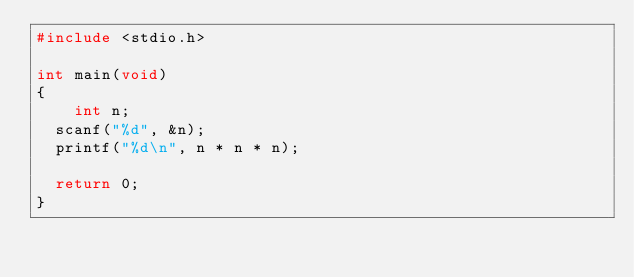<code> <loc_0><loc_0><loc_500><loc_500><_C_>#include <stdio.h>

int main(void)
{
    int n;
	scanf("%d", &n);
	printf("%d\n", n * n * n);

	return 0;
}</code> 